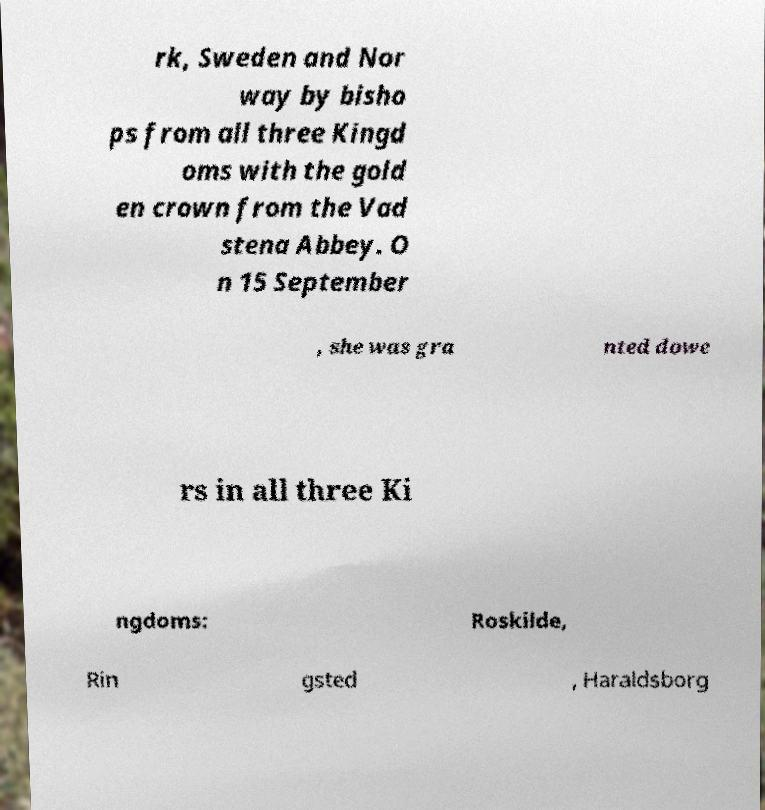Can you accurately transcribe the text from the provided image for me? rk, Sweden and Nor way by bisho ps from all three Kingd oms with the gold en crown from the Vad stena Abbey. O n 15 September , she was gra nted dowe rs in all three Ki ngdoms: Roskilde, Rin gsted , Haraldsborg 